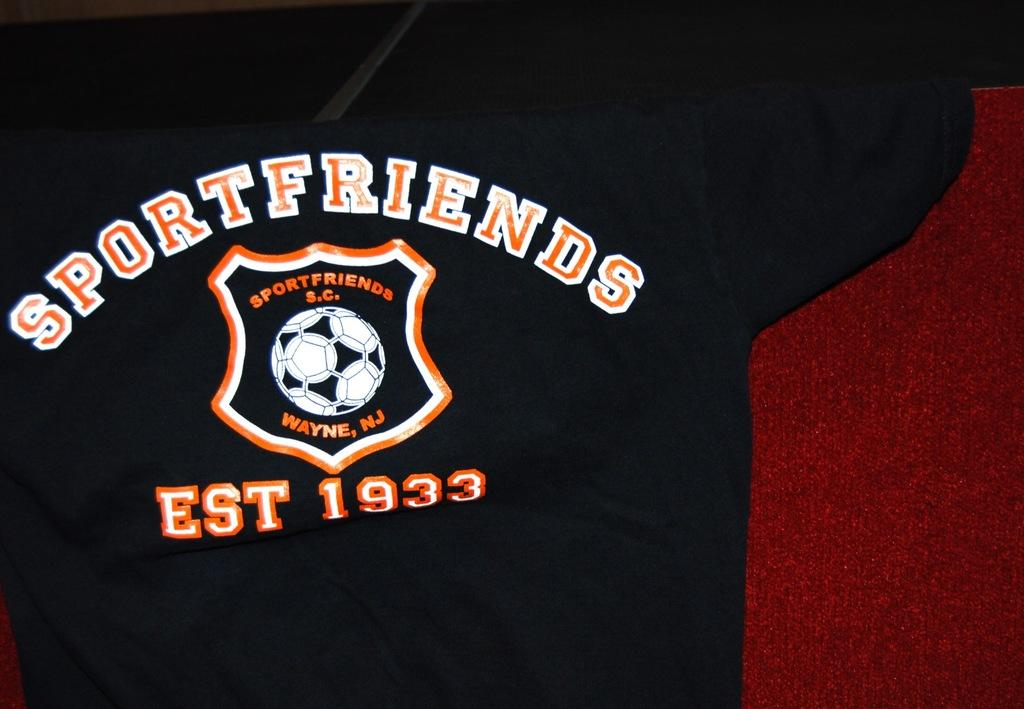<image>
Provide a brief description of the given image. A jersey represents Sportfriends in the town of Wayne, New Jersey. 